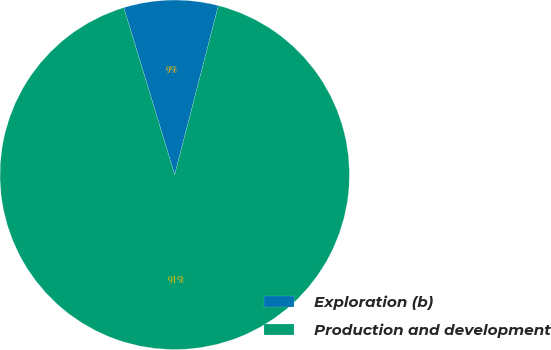<chart> <loc_0><loc_0><loc_500><loc_500><pie_chart><fcel>Exploration (b)<fcel>Production and development<nl><fcel>8.73%<fcel>91.27%<nl></chart> 